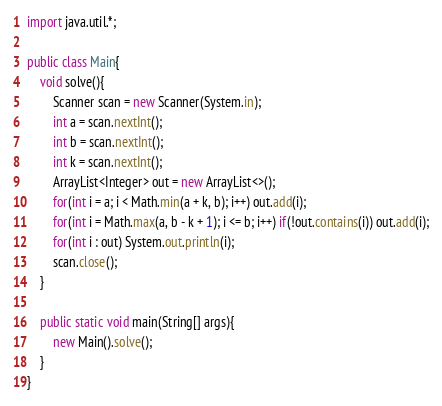Convert code to text. <code><loc_0><loc_0><loc_500><loc_500><_Java_>import java.util.*;

public class Main{
    void solve(){
        Scanner scan = new Scanner(System.in);
        int a = scan.nextInt();
        int b = scan.nextInt();
        int k = scan.nextInt();
        ArrayList<Integer> out = new ArrayList<>();
        for(int i = a; i < Math.min(a + k, b); i++) out.add(i);
        for(int i = Math.max(a, b - k + 1); i <= b; i++) if(!out.contains(i)) out.add(i);
        for(int i : out) System.out.println(i);
        scan.close();
    }

    public static void main(String[] args){
        new Main().solve();
    }
}
</code> 